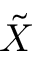<formula> <loc_0><loc_0><loc_500><loc_500>\tilde { X }</formula> 